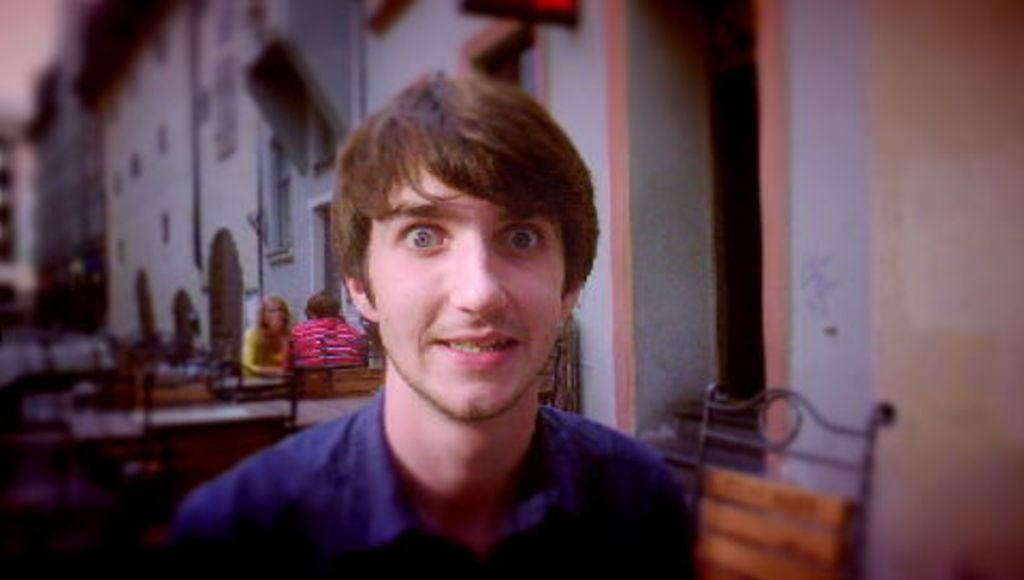Who is the main subject in the image? There is a man in the center of the image. What can be seen in the background of the image? There are persons, tables, chairs, buildings, a door, windows, and a wall in the background of the image. Can you describe the setting of the image? The image appears to be set in an outdoor area with tables, chairs, and buildings in the background. What type of cork is being used to hold the government documents in the image? There is no cork or government documents present in the image. 